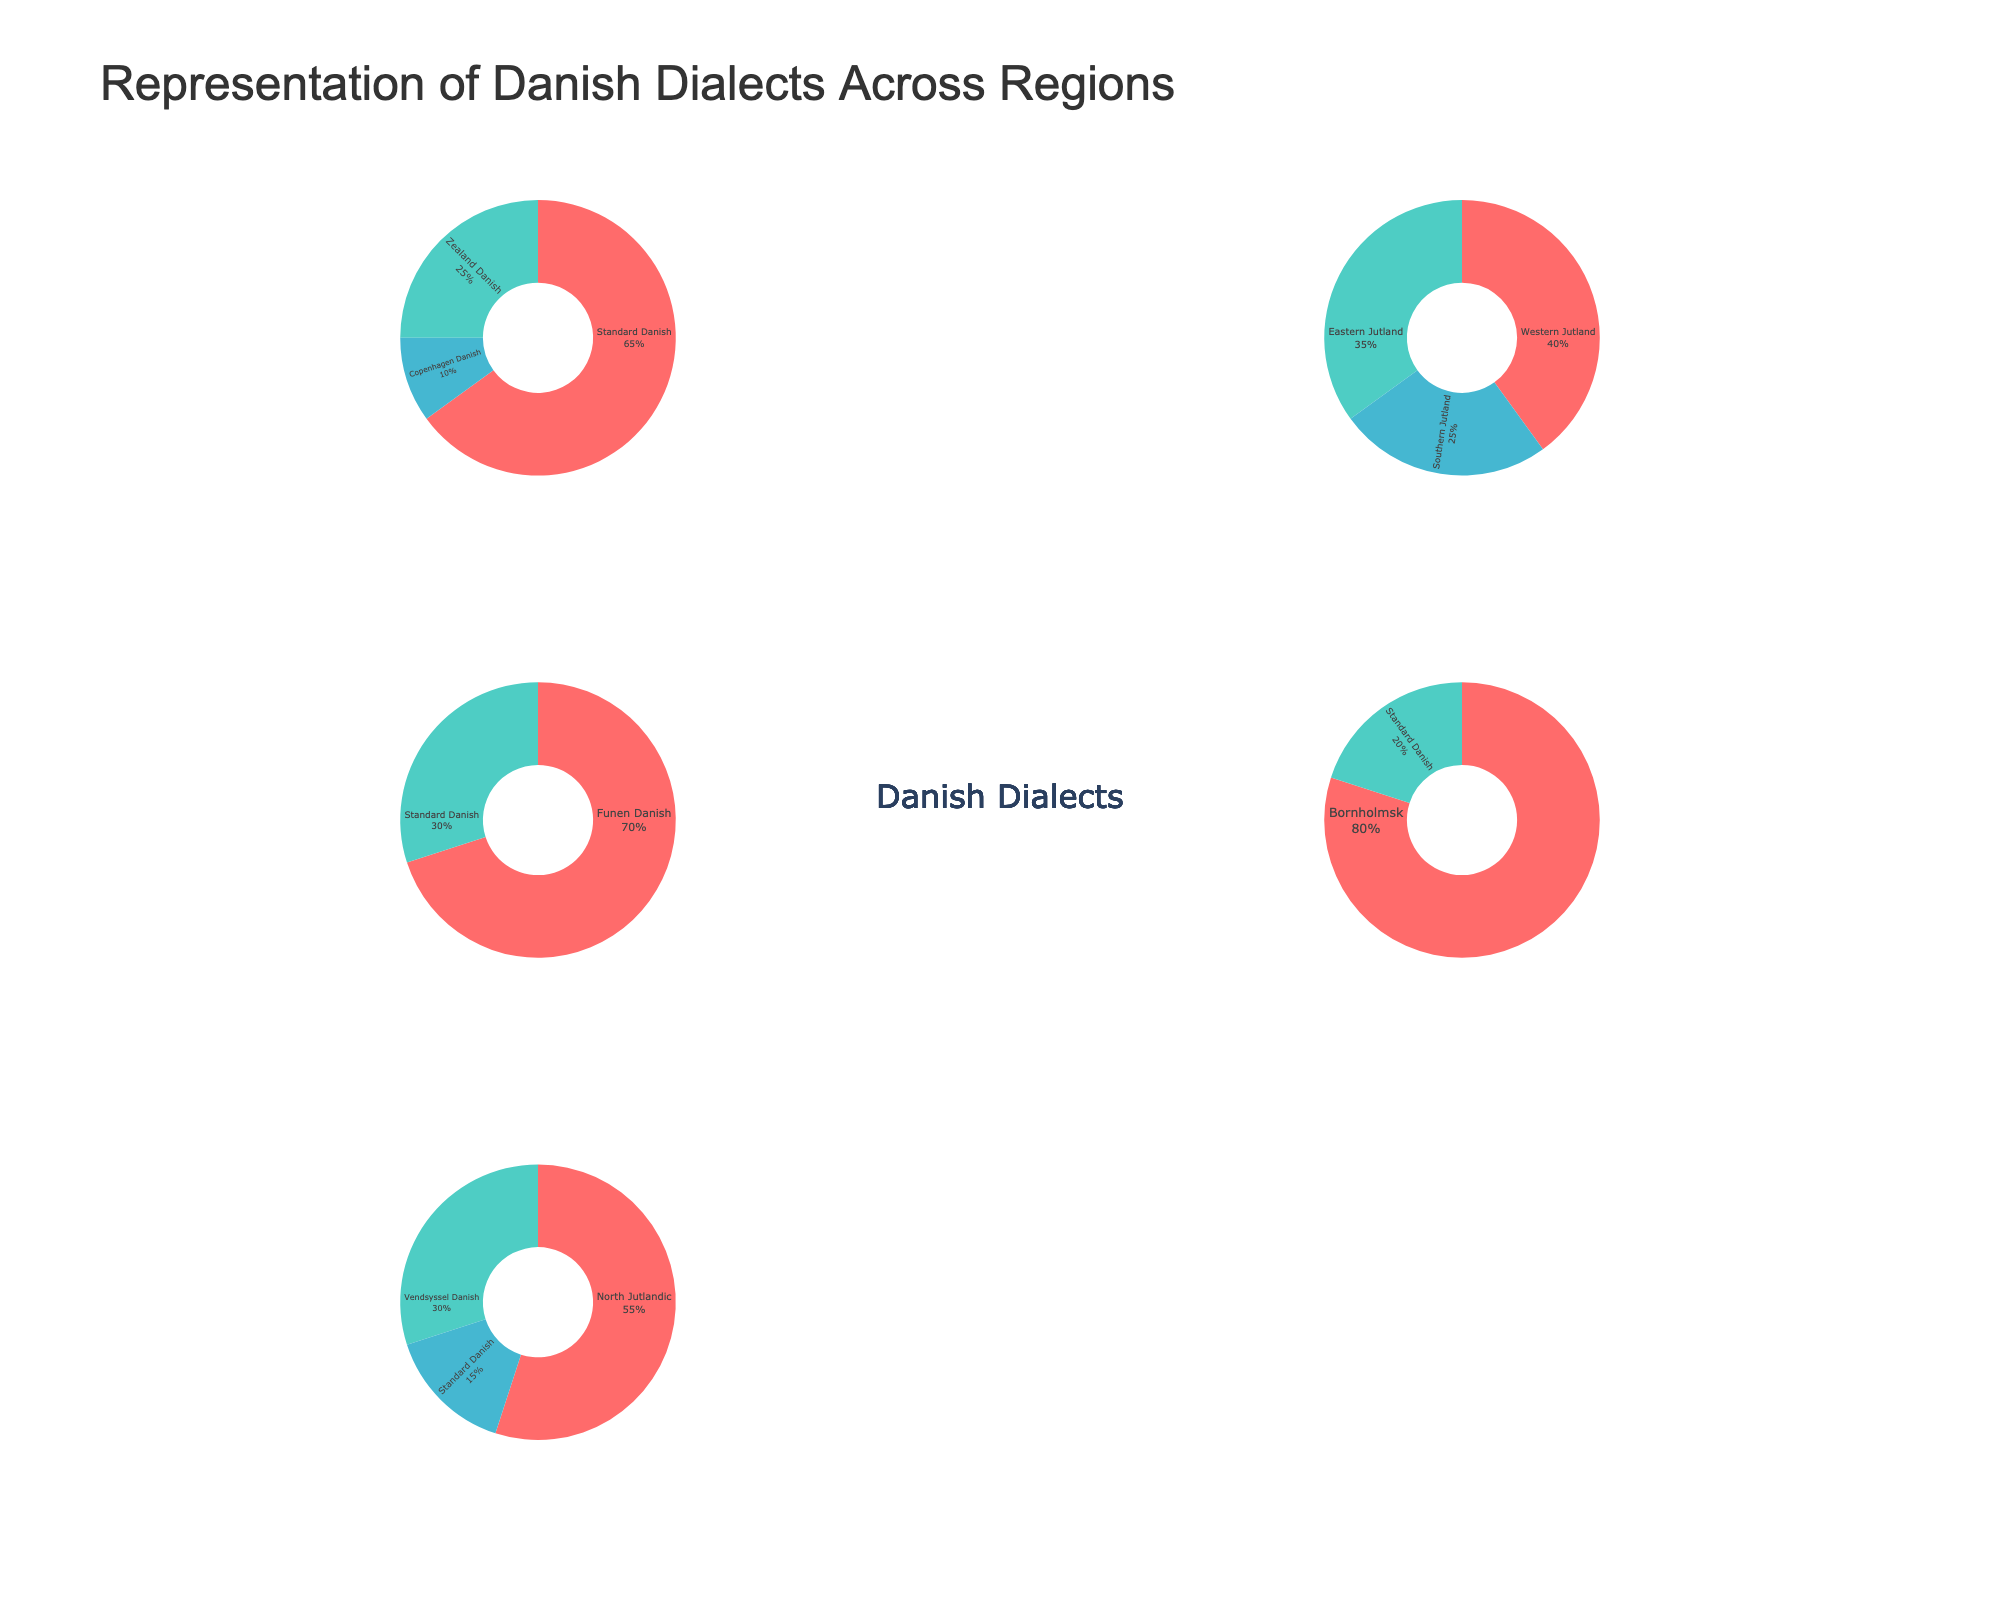how many shipping methods are shown for the Northeast region? First, locate the subplot for the Northeast region. Then, count the number of distinct shipping method bubbles shown. There are three: Truck, Rail, and Air.
Answer: 3 which region has the highest cost per unit for air shipping? Find the subplots where air shipping is used and compare the costs per unit associated with air shipping. The subplots for Air show $12.00 for the West and $15.00 for Alaska. Alaska has the highest cost per unit for air shipping.
Answer: Alaska which shipping method has the smallest bubble in the Alaska region? Locate the Alaska subplot and compare the sizes of the bubbles for each shipping method. The smallest bubble corresponds to the Truck shipping method.
Answer: Truck what is the delivery time for rail shipping in the Midwest region? Locate the subplot for the Midwest region and find the bubble for rail shipping. The x-axis value of this bubble represents the delivery time in days. It is 6 days.
Answer: 6 days which shipping method in the South region has the shortest delivery time? Find the subplot for the South region and compare the x-axis values for each shipping method. The bubble for air shipping has the smallest x-axis value, indicating the shortest delivery time.
Answer: Air 